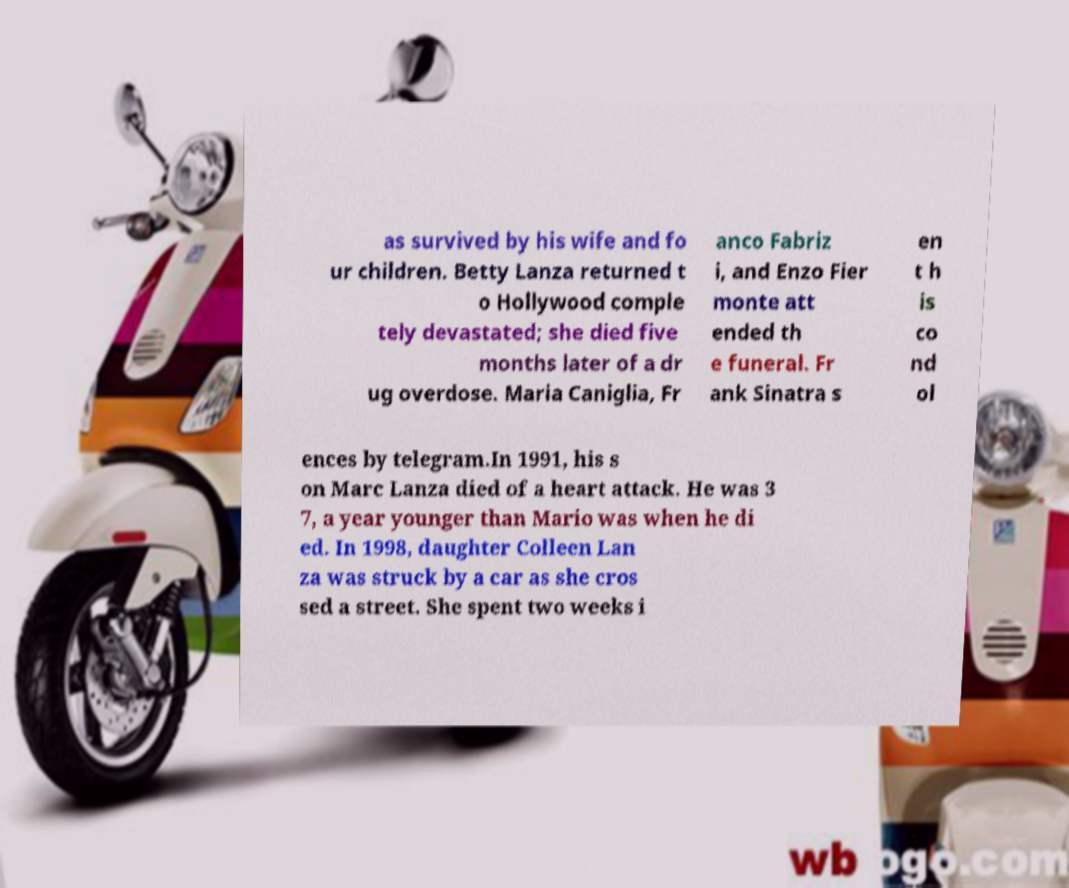Can you read and provide the text displayed in the image?This photo seems to have some interesting text. Can you extract and type it out for me? as survived by his wife and fo ur children. Betty Lanza returned t o Hollywood comple tely devastated; she died five months later of a dr ug overdose. Maria Caniglia, Fr anco Fabriz i, and Enzo Fier monte att ended th e funeral. Fr ank Sinatra s en t h is co nd ol ences by telegram.In 1991, his s on Marc Lanza died of a heart attack. He was 3 7, a year younger than Mario was when he di ed. In 1998, daughter Colleen Lan za was struck by a car as she cros sed a street. She spent two weeks i 